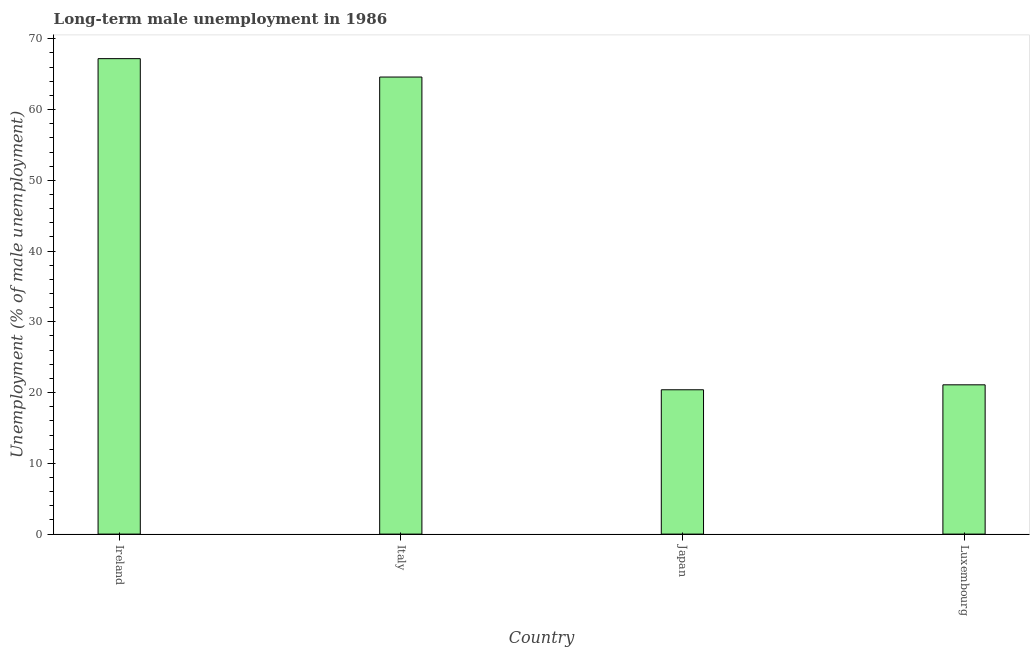Does the graph contain grids?
Offer a very short reply. No. What is the title of the graph?
Provide a short and direct response. Long-term male unemployment in 1986. What is the label or title of the X-axis?
Your answer should be compact. Country. What is the label or title of the Y-axis?
Your answer should be compact. Unemployment (% of male unemployment). What is the long-term male unemployment in Luxembourg?
Keep it short and to the point. 21.1. Across all countries, what is the maximum long-term male unemployment?
Ensure brevity in your answer.  67.2. Across all countries, what is the minimum long-term male unemployment?
Keep it short and to the point. 20.4. In which country was the long-term male unemployment maximum?
Provide a short and direct response. Ireland. In which country was the long-term male unemployment minimum?
Offer a very short reply. Japan. What is the sum of the long-term male unemployment?
Your response must be concise. 173.3. What is the difference between the long-term male unemployment in Italy and Luxembourg?
Your answer should be very brief. 43.5. What is the average long-term male unemployment per country?
Give a very brief answer. 43.33. What is the median long-term male unemployment?
Your answer should be compact. 42.85. In how many countries, is the long-term male unemployment greater than 12 %?
Keep it short and to the point. 4. What is the ratio of the long-term male unemployment in Japan to that in Luxembourg?
Your response must be concise. 0.97. What is the difference between the highest and the lowest long-term male unemployment?
Your answer should be very brief. 46.8. Are all the bars in the graph horizontal?
Make the answer very short. No. What is the Unemployment (% of male unemployment) of Ireland?
Your answer should be compact. 67.2. What is the Unemployment (% of male unemployment) in Italy?
Offer a very short reply. 64.6. What is the Unemployment (% of male unemployment) in Japan?
Your answer should be very brief. 20.4. What is the Unemployment (% of male unemployment) of Luxembourg?
Offer a very short reply. 21.1. What is the difference between the Unemployment (% of male unemployment) in Ireland and Italy?
Your answer should be compact. 2.6. What is the difference between the Unemployment (% of male unemployment) in Ireland and Japan?
Give a very brief answer. 46.8. What is the difference between the Unemployment (% of male unemployment) in Ireland and Luxembourg?
Your answer should be very brief. 46.1. What is the difference between the Unemployment (% of male unemployment) in Italy and Japan?
Offer a very short reply. 44.2. What is the difference between the Unemployment (% of male unemployment) in Italy and Luxembourg?
Give a very brief answer. 43.5. What is the ratio of the Unemployment (% of male unemployment) in Ireland to that in Italy?
Offer a terse response. 1.04. What is the ratio of the Unemployment (% of male unemployment) in Ireland to that in Japan?
Give a very brief answer. 3.29. What is the ratio of the Unemployment (% of male unemployment) in Ireland to that in Luxembourg?
Your answer should be compact. 3.19. What is the ratio of the Unemployment (% of male unemployment) in Italy to that in Japan?
Your answer should be very brief. 3.17. What is the ratio of the Unemployment (% of male unemployment) in Italy to that in Luxembourg?
Your answer should be very brief. 3.06. What is the ratio of the Unemployment (% of male unemployment) in Japan to that in Luxembourg?
Provide a succinct answer. 0.97. 